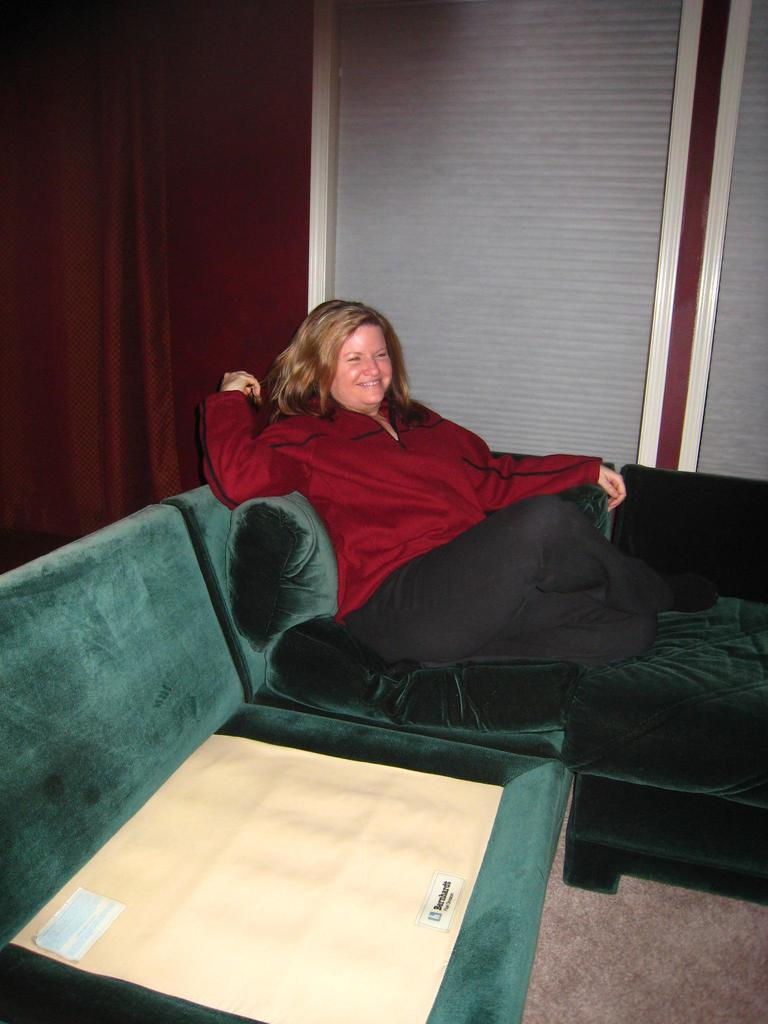Who is present in the image? There is a woman in the image. What is the woman doing in the image? The woman is sitting on a couch and smiling. What can be seen in the background of the image? There is a wall in the background of the image. How many clocks are hanging on the wall behind the woman in the image? There is no mention of clocks in the image, so it is not possible to determine how many are hanging on the wall. 